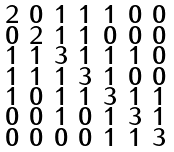<formula> <loc_0><loc_0><loc_500><loc_500>\begin{smallmatrix} 2 & 0 & 1 & 1 & 1 & 0 & 0 \\ 0 & 2 & 1 & 1 & 0 & 0 & 0 \\ 1 & 1 & 3 & 1 & 1 & 1 & 0 \\ 1 & 1 & 1 & 3 & 1 & 0 & 0 \\ 1 & 0 & 1 & 1 & 3 & 1 & 1 \\ 0 & 0 & 1 & 0 & 1 & 3 & 1 \\ 0 & 0 & 0 & 0 & 1 & 1 & 3 \end{smallmatrix}</formula> 